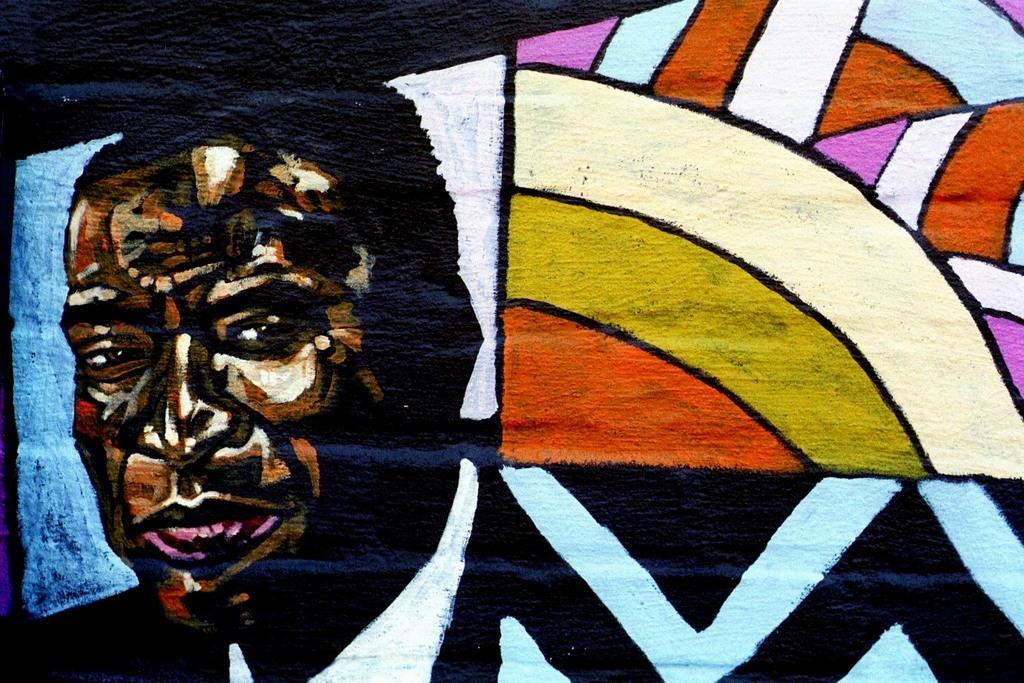What is depicted on the left side of the image? There is a painting of a man on the left side of the image. What is the subject of the painting? The painting is of a man. What can be observed on the right side of the image? The right side of the image is colorful. How many children are playing with a plate on the left side of the image? There are no children or plates present on the left side of the image; it features a painting of a man. What type of winter clothing is worn by the man in the painting? The painting does not depict the man wearing any winter clothing, as it is a painting and not a photograph. 